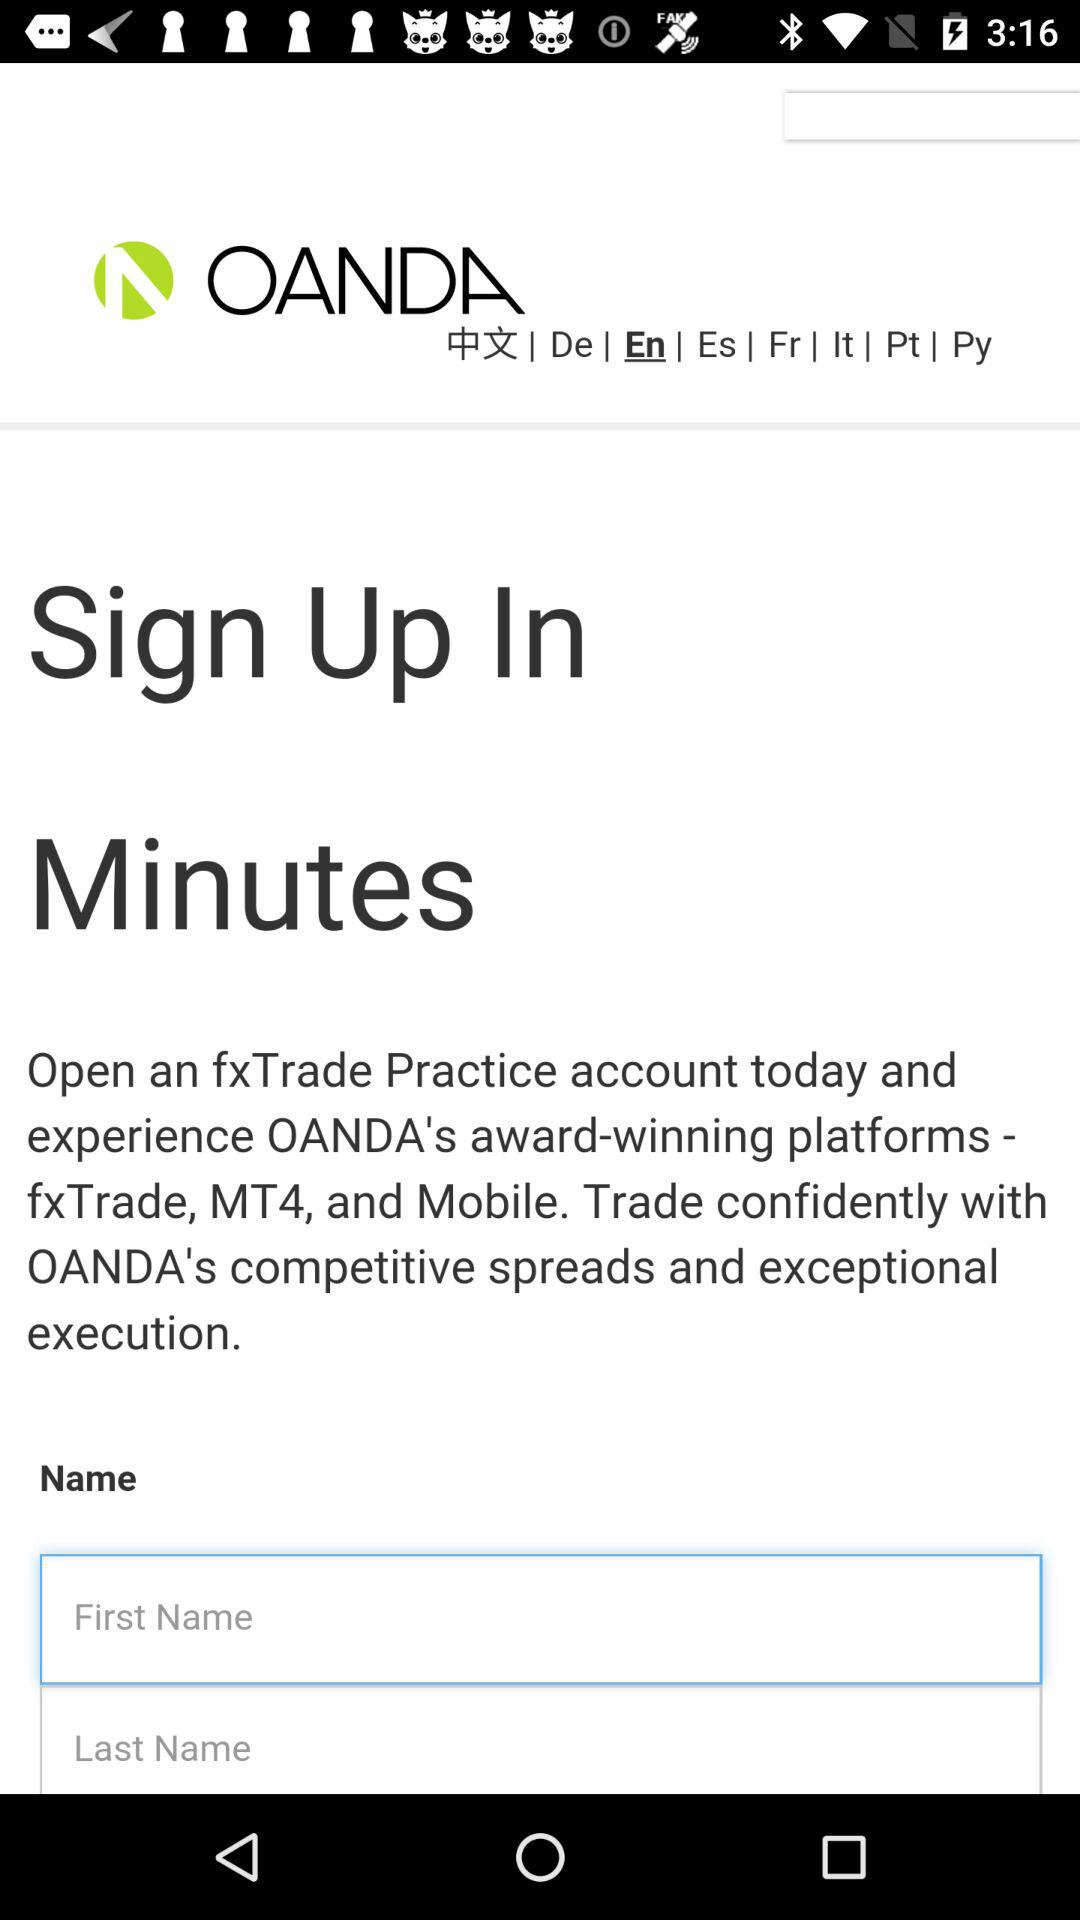What is the name of the application? The name of the application is "OANDA". 